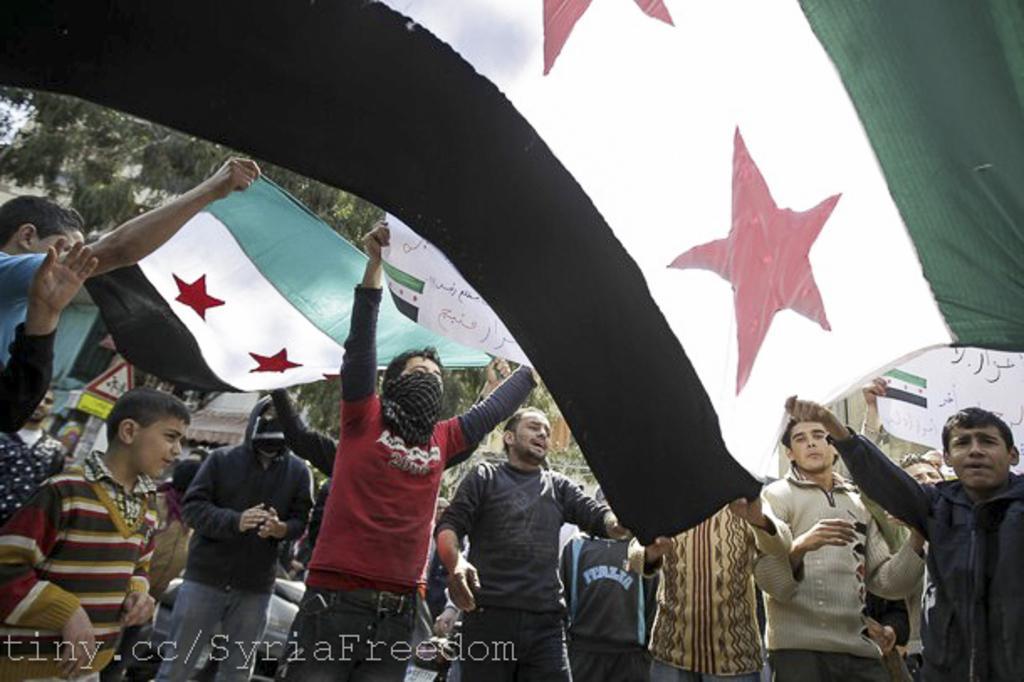Describe this image in one or two sentences. In this picture there are many people standing. To the right there is a man with black jacket is holding a flag in his hand. On the top of the flag there is green color, In middle is white color with stars and to the bottom it is black color. In the background there are some trees, sign board, stores. And to the left side there is a boy standing with red,black and white color. Beside him there is a man with black jacket is standing. And in the middle there is a person with black and red t-shirt is standing. And to his face there is a mask. 